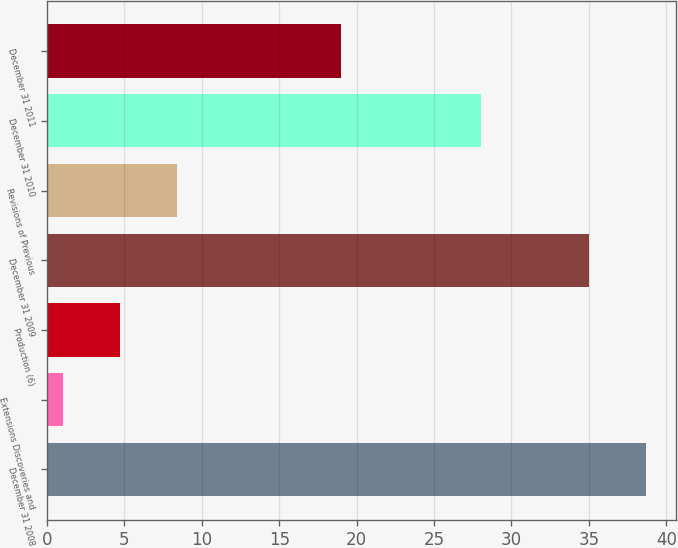<chart> <loc_0><loc_0><loc_500><loc_500><bar_chart><fcel>December 31 2008<fcel>Extensions Discoveries and<fcel>Production (6)<fcel>December 31 2009<fcel>Revisions of Previous<fcel>December 31 2010<fcel>December 31 2011<nl><fcel>38.7<fcel>1<fcel>4.7<fcel>35<fcel>8.4<fcel>28<fcel>19<nl></chart> 